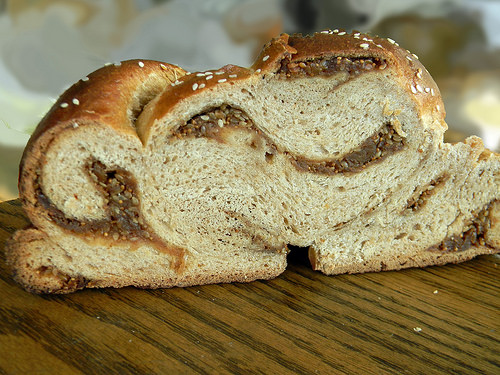<image>
Is the bun behind the ingrediants? No. The bun is not behind the ingrediants. From this viewpoint, the bun appears to be positioned elsewhere in the scene. 